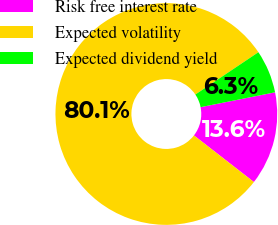Convert chart to OTSL. <chart><loc_0><loc_0><loc_500><loc_500><pie_chart><fcel>Risk free interest rate<fcel>Expected volatility<fcel>Expected dividend yield<nl><fcel>13.65%<fcel>80.08%<fcel>6.27%<nl></chart> 